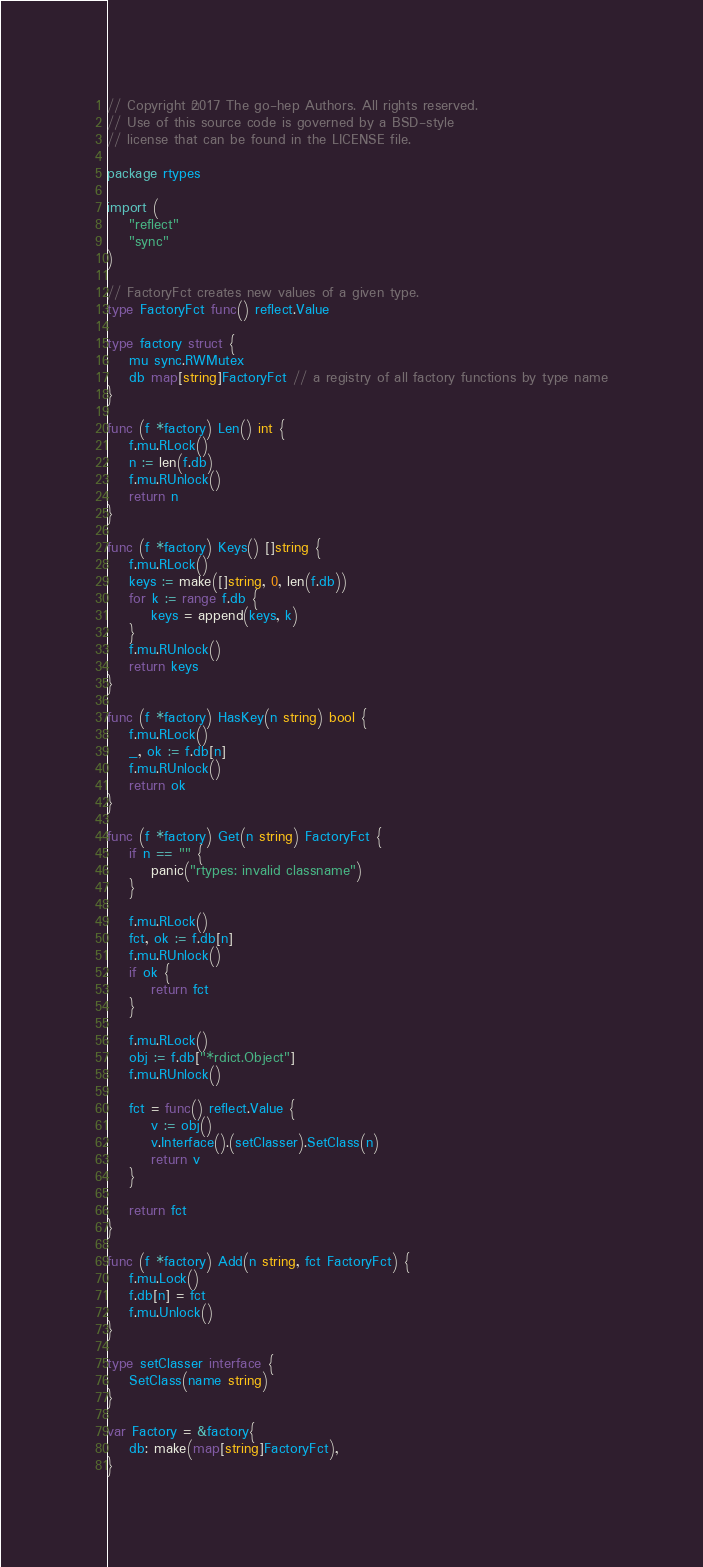Convert code to text. <code><loc_0><loc_0><loc_500><loc_500><_Go_>// Copyright ©2017 The go-hep Authors. All rights reserved.
// Use of this source code is governed by a BSD-style
// license that can be found in the LICENSE file.

package rtypes

import (
	"reflect"
	"sync"
)

// FactoryFct creates new values of a given type.
type FactoryFct func() reflect.Value

type factory struct {
	mu sync.RWMutex
	db map[string]FactoryFct // a registry of all factory functions by type name
}

func (f *factory) Len() int {
	f.mu.RLock()
	n := len(f.db)
	f.mu.RUnlock()
	return n
}

func (f *factory) Keys() []string {
	f.mu.RLock()
	keys := make([]string, 0, len(f.db))
	for k := range f.db {
		keys = append(keys, k)
	}
	f.mu.RUnlock()
	return keys
}

func (f *factory) HasKey(n string) bool {
	f.mu.RLock()
	_, ok := f.db[n]
	f.mu.RUnlock()
	return ok
}

func (f *factory) Get(n string) FactoryFct {
	if n == "" {
		panic("rtypes: invalid classname")
	}

	f.mu.RLock()
	fct, ok := f.db[n]
	f.mu.RUnlock()
	if ok {
		return fct
	}

	f.mu.RLock()
	obj := f.db["*rdict.Object"]
	f.mu.RUnlock()

	fct = func() reflect.Value {
		v := obj()
		v.Interface().(setClasser).SetClass(n)
		return v
	}

	return fct
}

func (f *factory) Add(n string, fct FactoryFct) {
	f.mu.Lock()
	f.db[n] = fct
	f.mu.Unlock()
}

type setClasser interface {
	SetClass(name string)
}

var Factory = &factory{
	db: make(map[string]FactoryFct),
}
</code> 